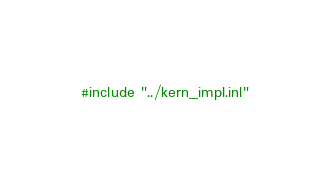Convert code to text. <code><loc_0><loc_0><loc_500><loc_500><_Cuda_>#include "../kern_impl.inl"
</code> 